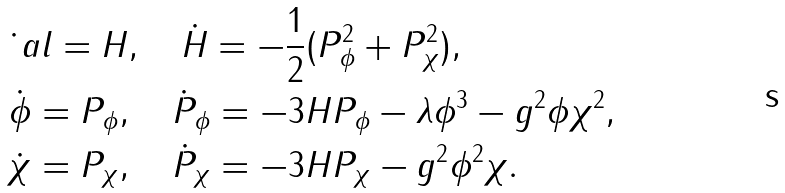<formula> <loc_0><loc_0><loc_500><loc_500>& \dot { \ } a l = H , \quad \dot { H } = - \frac { 1 } { 2 } ( P _ { \phi } ^ { 2 } + P _ { \chi } ^ { 2 } ) , \\ & \dot { \phi } = P _ { \phi } , \quad \dot { P } _ { \phi } = - 3 H P _ { \phi } - \lambda \phi ^ { 3 } - g ^ { 2 } \phi \chi ^ { 2 } , \\ & \dot { \chi } = P _ { \chi } , \quad \dot { P } _ { \chi } = - 3 H P _ { \chi } - g ^ { 2 } \phi ^ { 2 } \chi .</formula> 